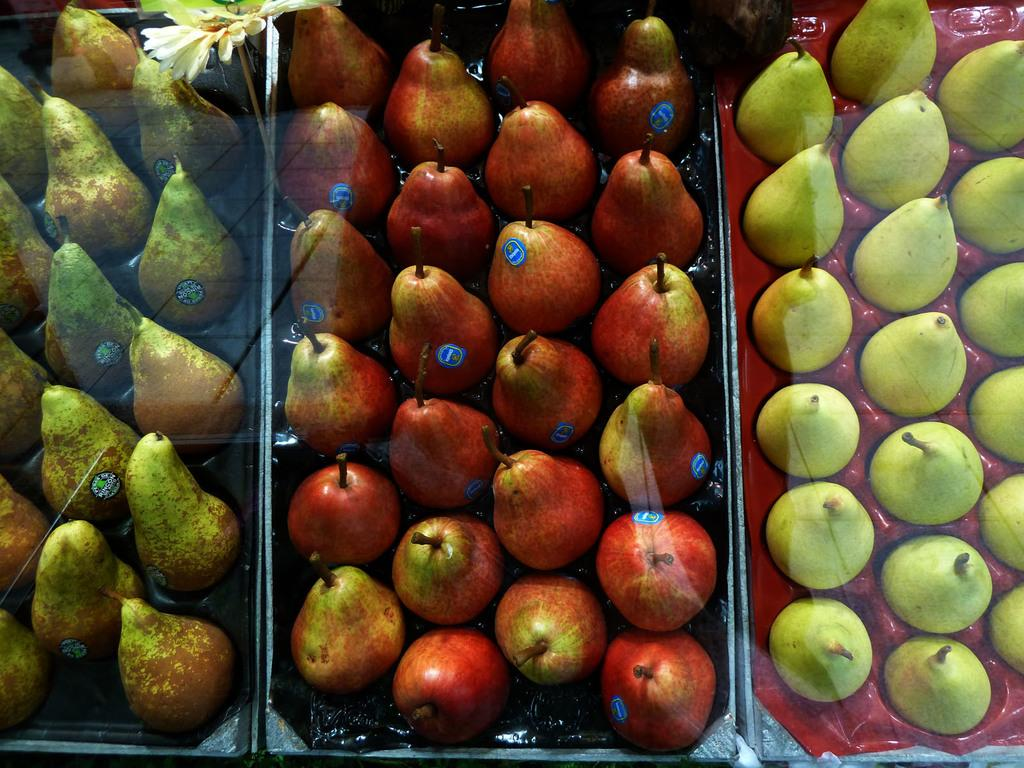What types of fruits are present in the image? There are bunches of different types of pears in the image. How are the pears arranged in the image? The pears are placed in trays. What is used to identify the type or variety of pears in the image? There are stickers attached to the pears. Can you describe any other object in the image besides the pears? There is an object in the image that resembles a flower. What type of experience can be seen in the image? There is no experience present in the image; it features bunches of pears, trays, stickers, and an object resembling a flower. Can you tell me how many deer are visible in the image? There are no deer present in the image. 